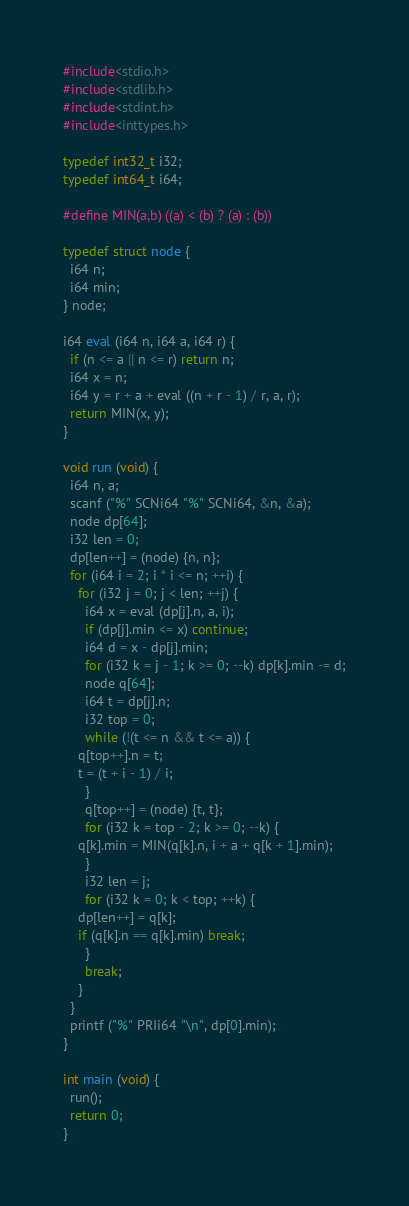Convert code to text. <code><loc_0><loc_0><loc_500><loc_500><_C_>#include<stdio.h>
#include<stdlib.h>
#include<stdint.h>
#include<inttypes.h>

typedef int32_t i32;
typedef int64_t i64;

#define MIN(a,b) ((a) < (b) ? (a) : (b))

typedef struct node {
  i64 n;
  i64 min;
} node;

i64 eval (i64 n, i64 a, i64 r) {
  if (n <= a || n <= r) return n;
  i64 x = n;
  i64 y = r + a + eval ((n + r - 1) / r, a, r);
  return MIN(x, y);
}

void run (void) {
  i64 n, a;
  scanf ("%" SCNi64 "%" SCNi64, &n, &a);
  node dp[64];
  i32 len = 0;
  dp[len++] = (node) {n, n};
  for (i64 i = 2; i * i <= n; ++i) {
    for (i32 j = 0; j < len; ++j) {
      i64 x = eval (dp[j].n, a, i);
      if (dp[j].min <= x) continue;
      i64 d = x - dp[j].min;
      for (i32 k = j - 1; k >= 0; --k) dp[k].min -= d;
      node q[64];
      i64 t = dp[j].n;
      i32 top = 0;
      while (!(t <= n && t <= a)) {
	q[top++].n = t;
	t = (t + i - 1) / i;
      }
      q[top++] = (node) {t, t};
      for (i32 k = top - 2; k >= 0; --k) {
	q[k].min = MIN(q[k].n, i + a + q[k + 1].min);
      }
      i32 len = j;
      for (i32 k = 0; k < top; ++k) {
	dp[len++] = q[k];
	if (q[k].n == q[k].min) break;
      }
      break;
    }
  }
  printf ("%" PRIi64 "\n", dp[0].min);
}

int main (void) {
  run();
  return 0;
}
</code> 